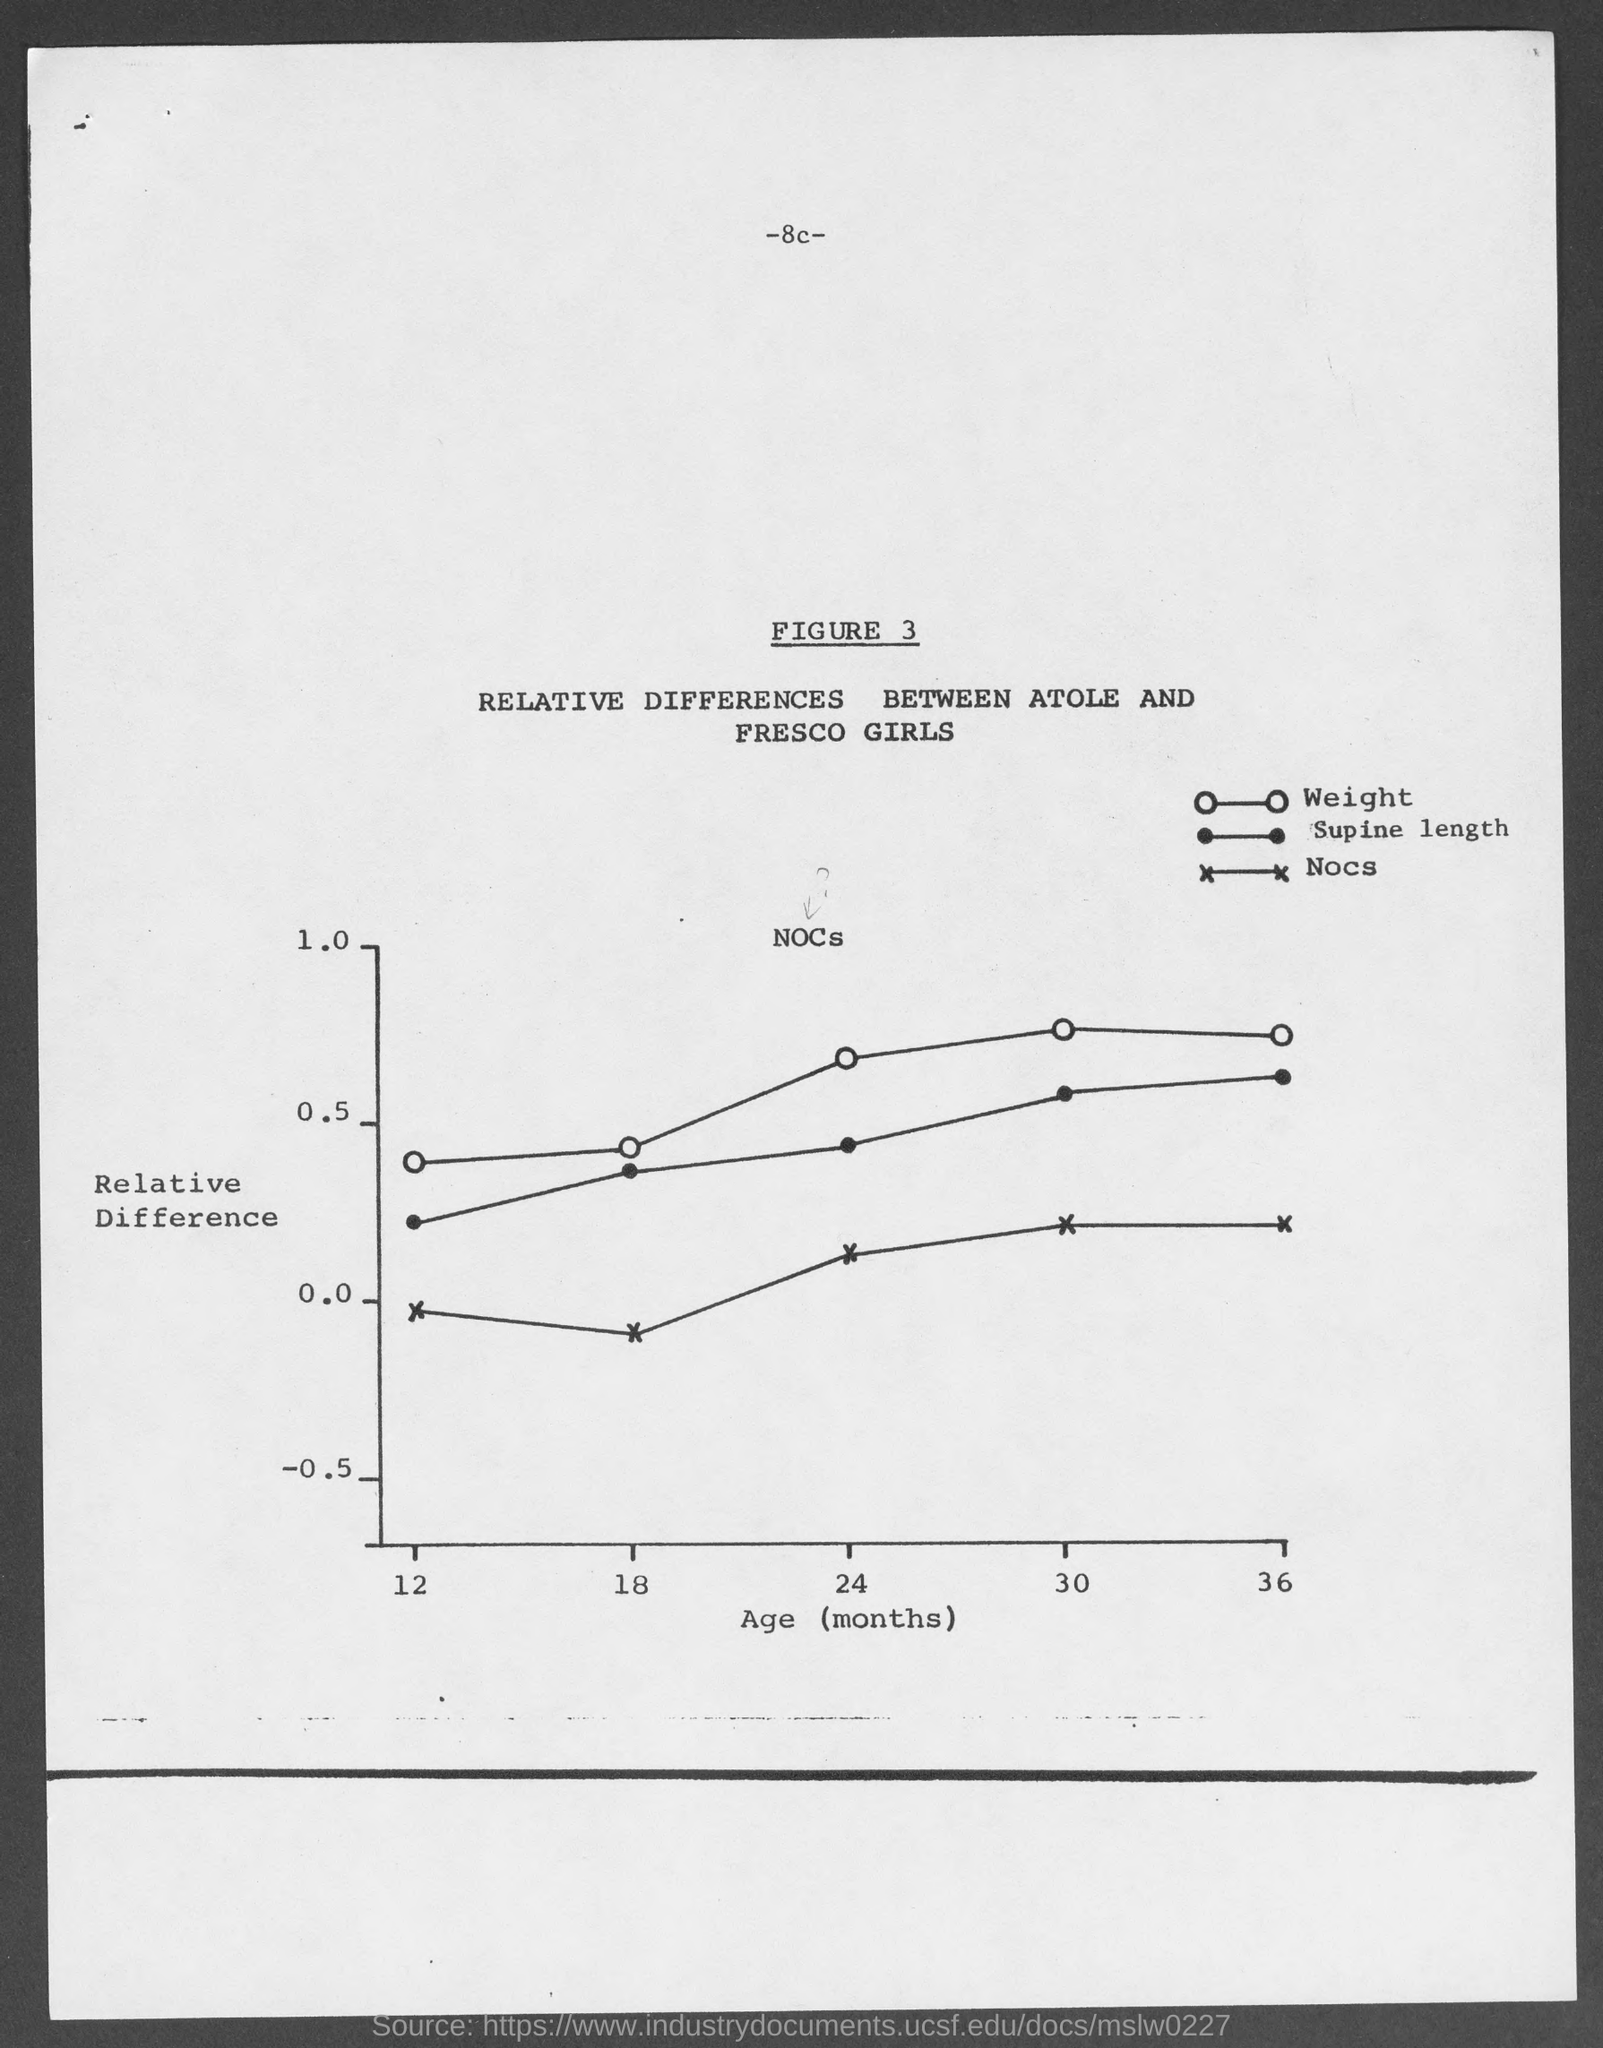what is the figure no.?
 3 